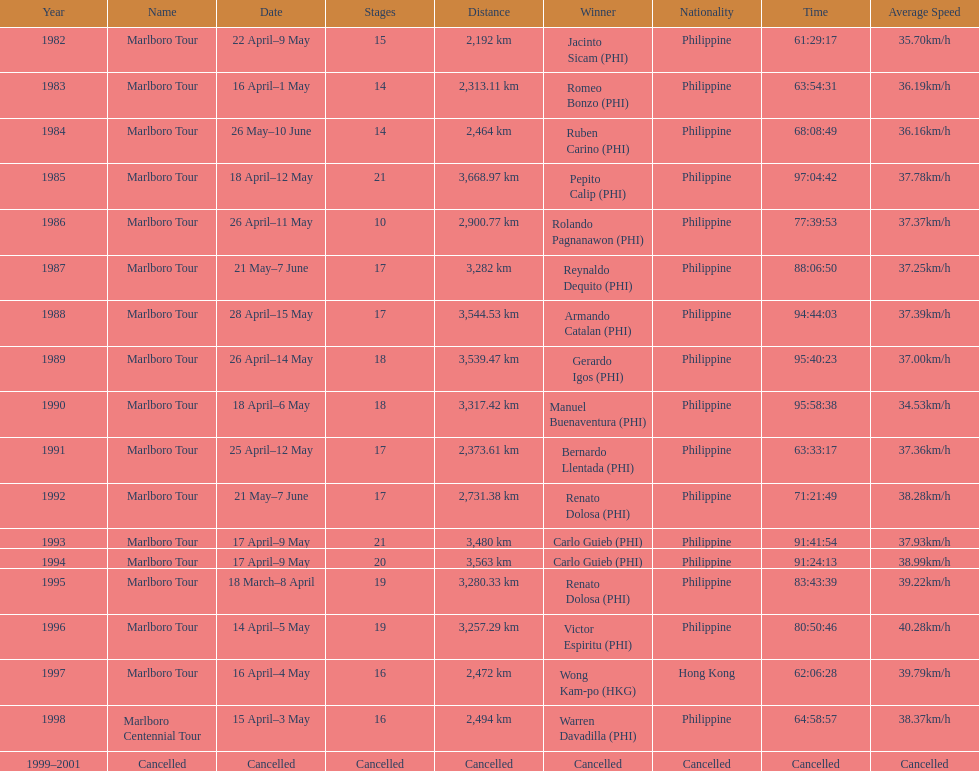What was the total number of winners before the tour was canceled? 17. 